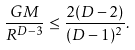Convert formula to latex. <formula><loc_0><loc_0><loc_500><loc_500>\frac { G M } { R ^ { D - 3 } } \leq \frac { 2 ( D - 2 ) } { ( D - 1 ) ^ { 2 } } .</formula> 